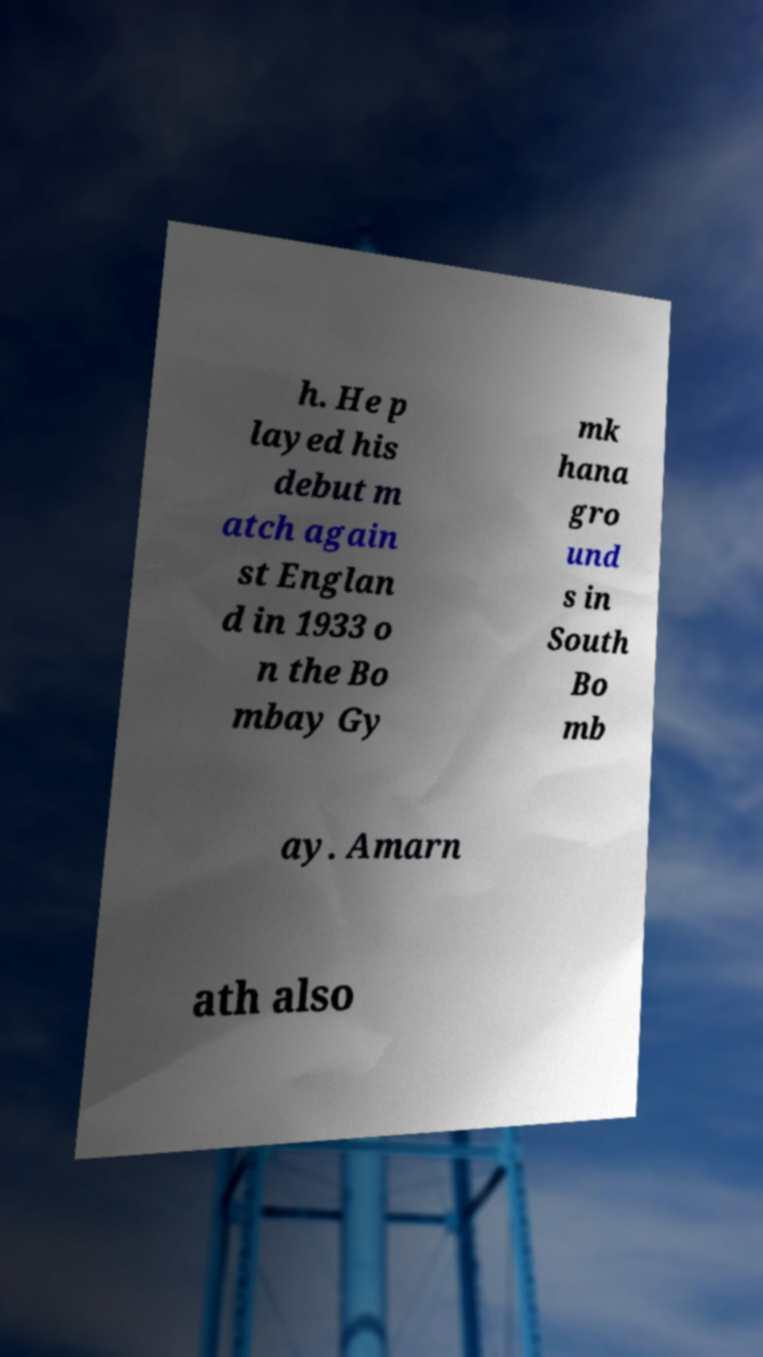Please identify and transcribe the text found in this image. h. He p layed his debut m atch again st Englan d in 1933 o n the Bo mbay Gy mk hana gro und s in South Bo mb ay. Amarn ath also 